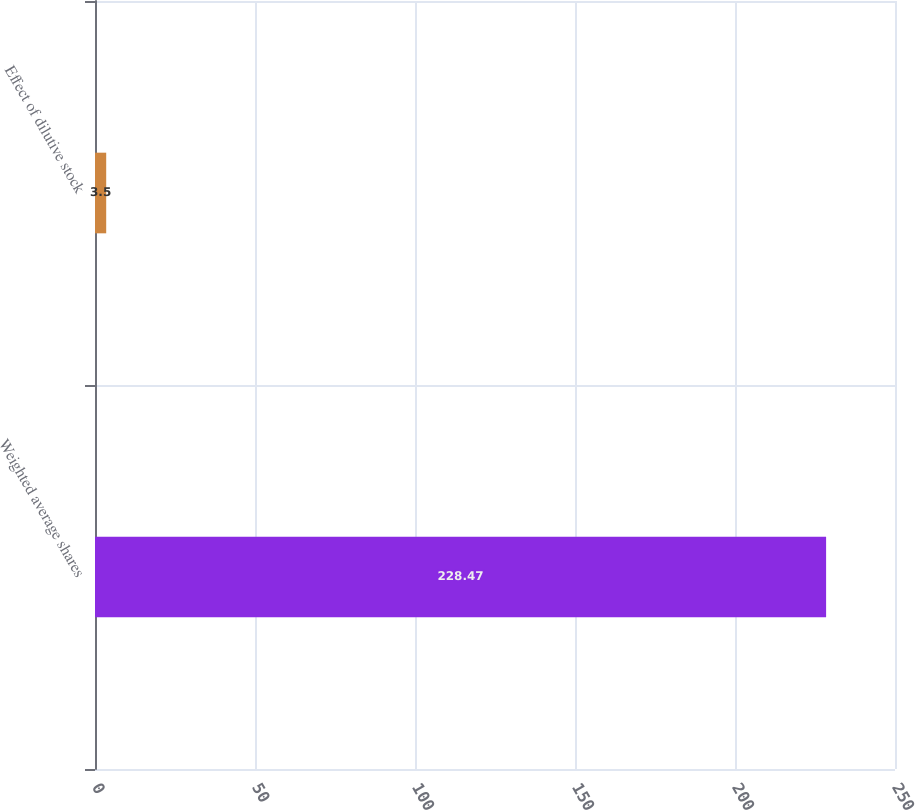Convert chart to OTSL. <chart><loc_0><loc_0><loc_500><loc_500><bar_chart><fcel>Weighted average shares<fcel>Effect of dilutive stock<nl><fcel>228.47<fcel>3.5<nl></chart> 